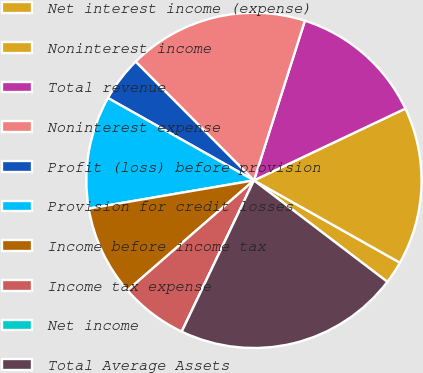Convert chart to OTSL. <chart><loc_0><loc_0><loc_500><loc_500><pie_chart><fcel>Net interest income (expense)<fcel>Noninterest income<fcel>Total revenue<fcel>Noninterest expense<fcel>Profit (loss) before provision<fcel>Provision for credit losses<fcel>Income before income tax<fcel>Income tax expense<fcel>Net income<fcel>Total Average Assets<nl><fcel>2.18%<fcel>15.22%<fcel>13.04%<fcel>17.39%<fcel>4.35%<fcel>10.87%<fcel>8.7%<fcel>6.52%<fcel>0.0%<fcel>21.74%<nl></chart> 